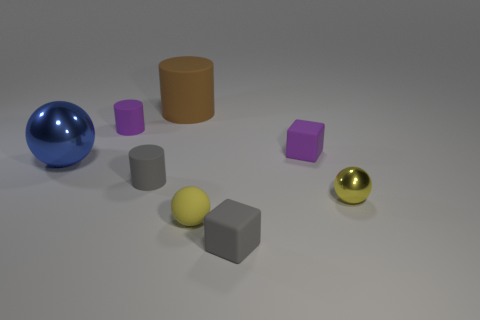Are there more purple matte blocks behind the small purple matte cube than small gray rubber things that are on the right side of the blue thing?
Provide a short and direct response. No. There is a matte cylinder that is in front of the tiny purple cylinder; what color is it?
Provide a short and direct response. Gray. Is there another rubber thing of the same shape as the blue thing?
Provide a short and direct response. Yes. What number of cyan things are small rubber objects or big matte things?
Give a very brief answer. 0. Are there any rubber balls of the same size as the yellow metallic sphere?
Your answer should be very brief. Yes. How many tiny metal spheres are there?
Provide a succinct answer. 1. What number of small objects are brown matte cylinders or blue metallic balls?
Your answer should be very brief. 0. There is a shiny sphere behind the small object to the right of the small cube that is behind the small yellow metal ball; what is its color?
Make the answer very short. Blue. How many other things are there of the same color as the big ball?
Your response must be concise. 0. What number of shiny things are brown objects or objects?
Keep it short and to the point. 2. 